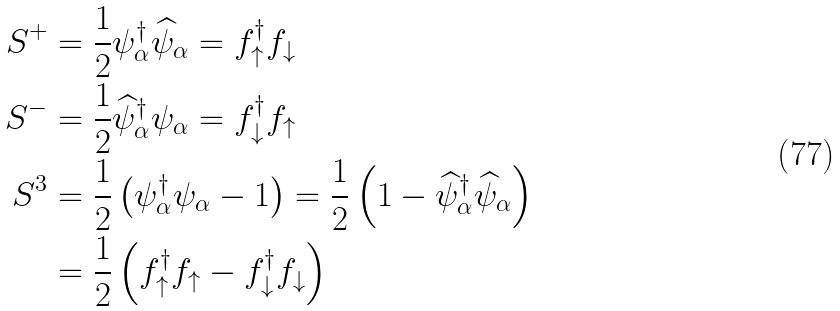<formula> <loc_0><loc_0><loc_500><loc_500>S ^ { + } & = \frac { 1 } { 2 } \psi _ { \alpha } ^ { \dag } \widehat { \psi } _ { \alpha } = f _ { \uparrow } ^ { \dag } f _ { \downarrow } \\ S ^ { - } & = \frac { 1 } { 2 } \widehat { \psi } _ { \alpha } ^ { \dag } \psi _ { \alpha } = f _ { \downarrow } ^ { \dag } f _ { \uparrow } \\ S ^ { 3 } & = \frac { 1 } { 2 } \left ( \psi _ { \alpha } ^ { \dag } \psi _ { \alpha } - 1 \right ) = \frac { 1 } { 2 } \left ( 1 - \widehat { \psi } _ { \alpha } ^ { \dag } \widehat { \psi } _ { \alpha } \right ) \\ & = \frac { 1 } { 2 } \left ( f _ { \uparrow } ^ { \dag } f _ { \uparrow } - f _ { \downarrow } ^ { \dag } f _ { \downarrow } \right )</formula> 